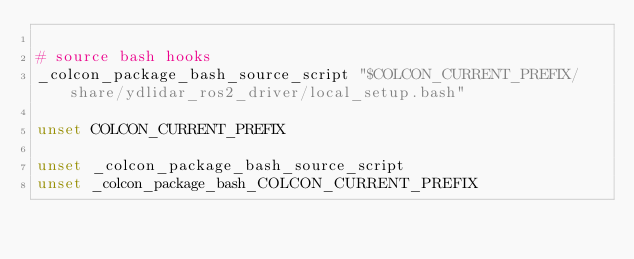Convert code to text. <code><loc_0><loc_0><loc_500><loc_500><_Bash_>
# source bash hooks
_colcon_package_bash_source_script "$COLCON_CURRENT_PREFIX/share/ydlidar_ros2_driver/local_setup.bash"

unset COLCON_CURRENT_PREFIX

unset _colcon_package_bash_source_script
unset _colcon_package_bash_COLCON_CURRENT_PREFIX
</code> 